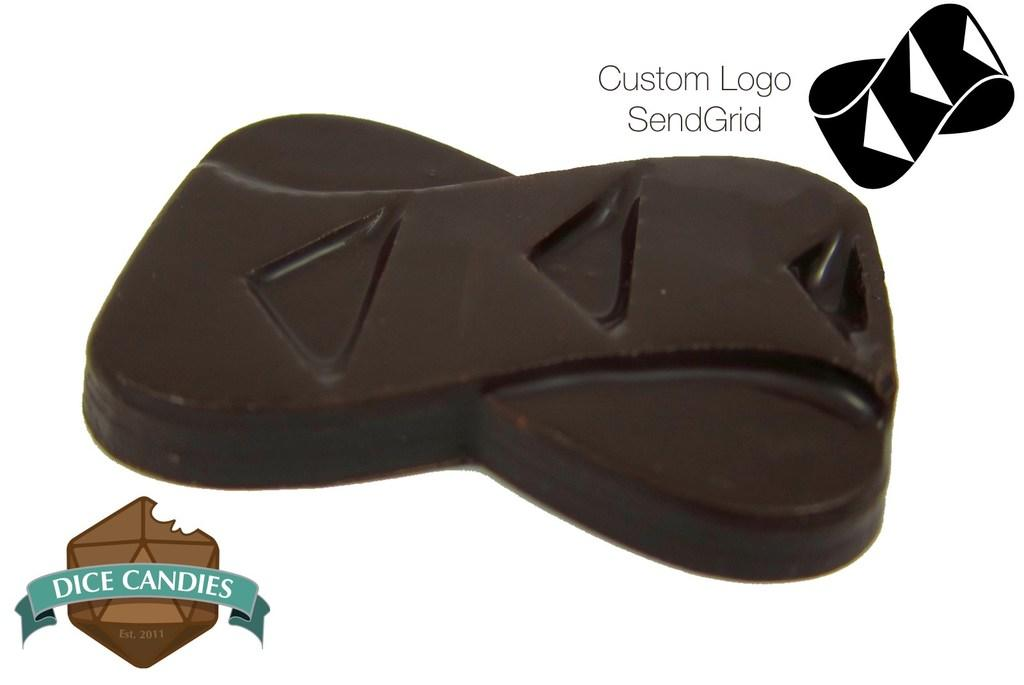What type of food item is present in the image? There is a chocolate bar in the image. Where can logos be found in the image? Logos can be found on the right side top and the left side bottom of the image. Is there any text present in the image? Yes, there is some text in the image. What type of government is depicted in the image? There is no depiction of a government in the image; it features a chocolate bar and logos. Can you describe the border between the logos on the right side top and the left side bottom of the image? There is no border between the logos in the image; they are simply located in different areas of the image. 